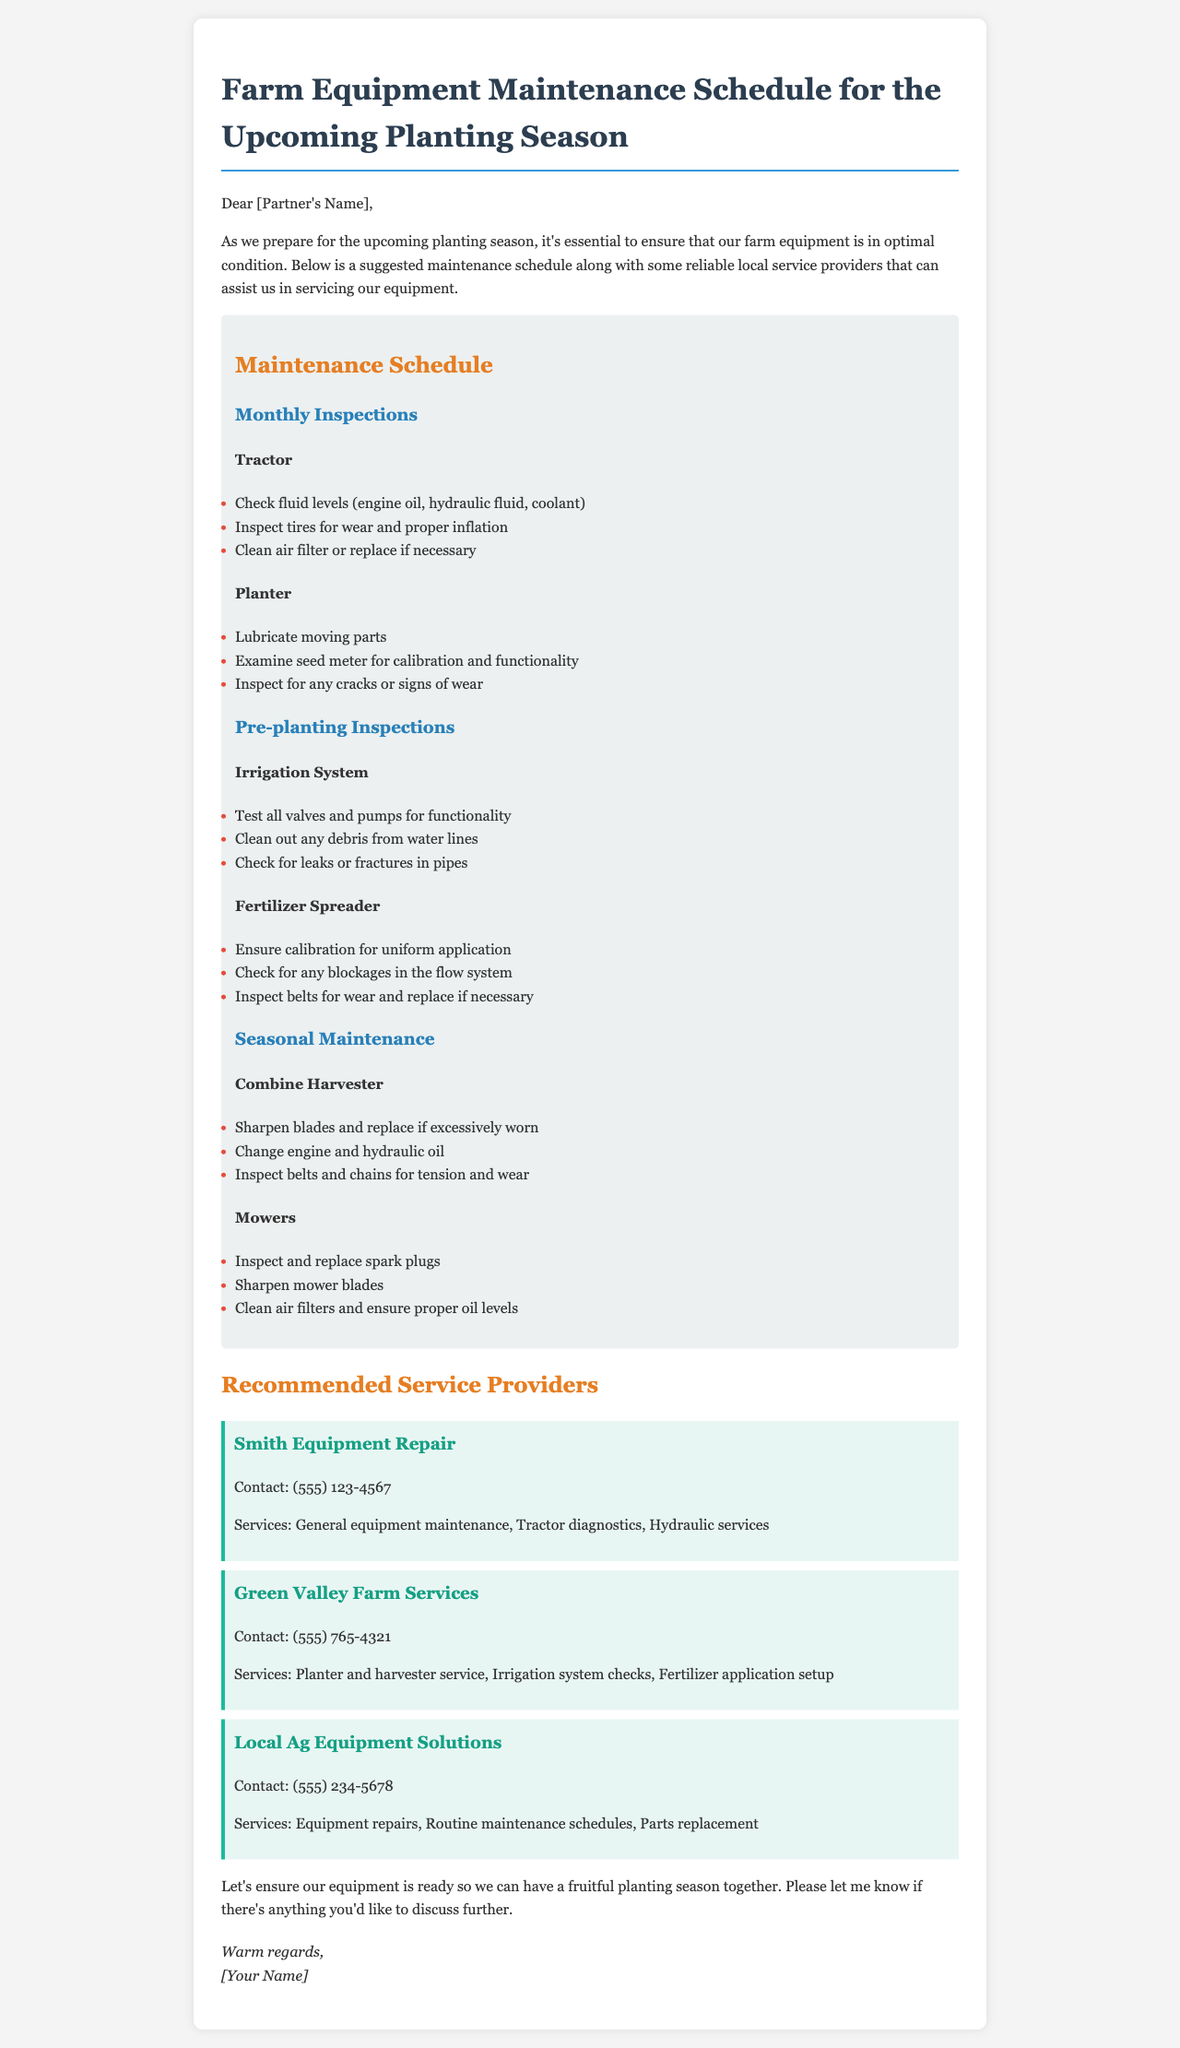What is the title of the document? The title of the document is prominently displayed at the beginning and indicates the focus on farm equipment maintenance.
Answer: Farm Equipment Maintenance Schedule for the Upcoming Planting Season How many service providers are recommended? The document lists three different service providers along with their details.
Answer: 3 What type of inspections are scheduled monthly for the tractor? The document includes specific tasks required during monthly inspections for the tractor under the maintenance schedule section.
Answer: Check fluid levels, Inspect tires, Clean air filter What services does Smith Equipment Repair provide? The document details the services offered by Smith Equipment Repair to indicate what they specialize in.
Answer: General equipment maintenance, Tractor diagnostics, Hydraulic services What should be done to the combine harvester during seasonal maintenance? This question summarizes the tasks specified in the document for maintaining the combine harvester from the maintenance schedule section.
Answer: Sharpen blades, Change oil, Inspect belts What task is suggested for the planter during monthly inspections? The document emphasizes the importance of lubricating moving parts as part of the maintenance schedule for the planter.
Answer: Lubricate moving parts Which service provider can assist with irrigation system checks? The document provides the services offered by Green Valley Farm Services including irrigation system checks.
Answer: Green Valley Farm Services What is the contact number for Local Ag Equipment Solutions? The document includes the contact information for Local Ag Equipment Solutions within the recommended service providers section.
Answer: (555) 234-5678 